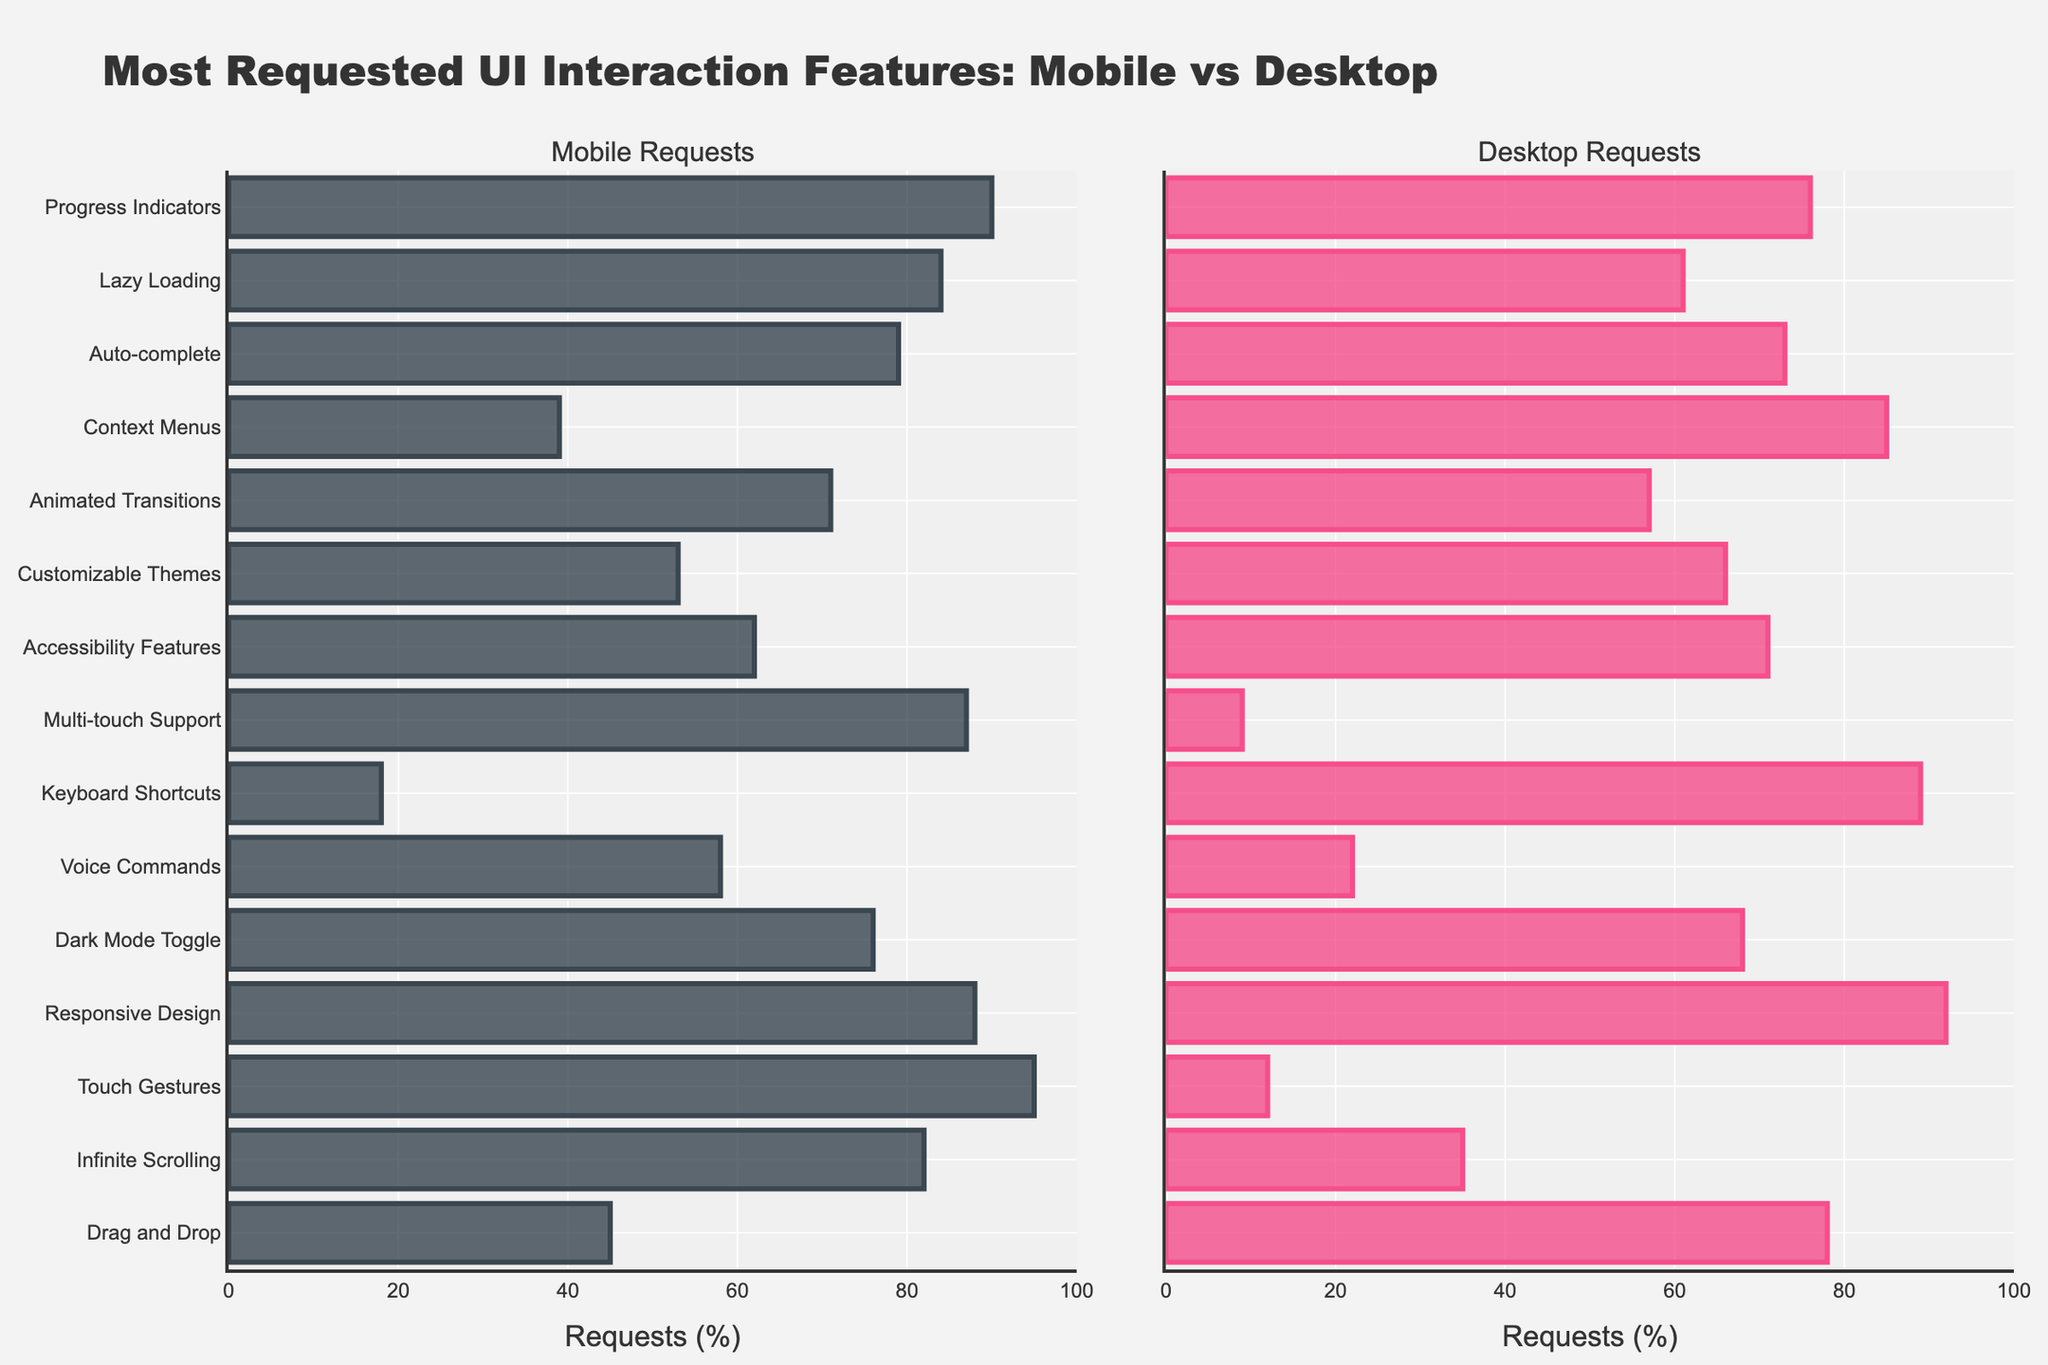Which type of UI interaction feature has the highest request percentage on mobile? Look for the tallest bar on the Mobile Requests side. "Touch Gestures" has the highest request at 95%.
Answer: Touch Gestures Which type of UI interaction feature has the highest request percentage on desktop? Look for the tallest bar on the Desktop Requests side. "Keyboard Shortcuts" has the highest request at 89%.
Answer: Keyboard Shortcuts What's the difference in request percentage for "Dark Mode Toggle" between mobile and desktop? Subtract the request percentage for "Dark Mode Toggle" on desktop (68%) from mobile (76%): 76% - 68% = 8%.
Answer: 8% Which feature shows a greater request difference between mobile and desktop, "Drag and Drop" or "Touch Gestures"? Calculate the differences: "Drag and Drop" (78% - 45% = 33%) and "Touch Gestures" (95% - 12% = 83%). "Touch Gestures" has a greater difference.
Answer: Touch Gestures Which feature appears to be equally favored on both mobile and desktop platforms? Look for bars with similar lengths in both columns. "Responsive Design" shows request percentages of 88% on mobile and 92% on desktop, which are very close.
Answer: Responsive Design How many features have higher request percentages on mobile than on desktop? Count the number of features where the bar on the Mobile Requests side is taller than its counterpart on the Desktop Requests side.
Answer: 11 For "Auto-complete", is the request percentage higher on mobile or desktop? Compare the lengths of the bars for "Auto-complete" in both categories. Mobile Requests is higher at 79% than Desktop Requests at 73%.
Answer: Mobile Which feature has the smallest request percentage on desktop? Look for the shortest bar on the Desktop Requests side. "Multi-touch Support" has the smallest request at 9%.
Answer: Multi-touch Support What's the average request percentage for "Animated Transitions" across both mobile and desktop? Sum the request percentages for "Animated Transitions" on both platforms (71% + 57%) and divide by 2. (71 + 57) / 2 = 64%.
Answer: 64% What percentage difference can be observed for "Context Menus" between mobile and desktop requests? Subtract the request percentage for "Context Menus" on mobile (39%) from desktop (85%): 85% - 39% = 46%.
Answer: 46% 